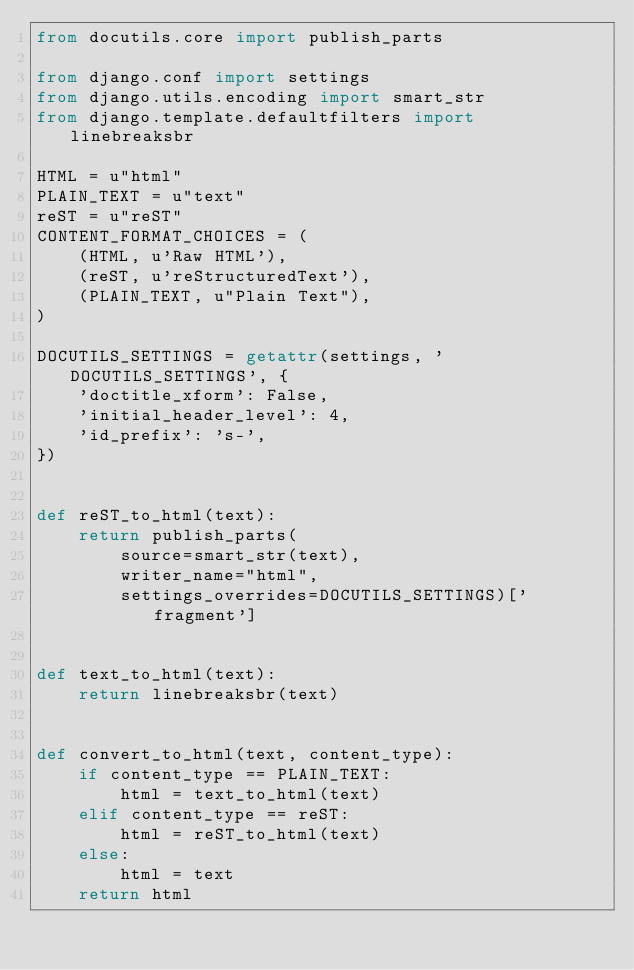<code> <loc_0><loc_0><loc_500><loc_500><_Python_>from docutils.core import publish_parts

from django.conf import settings
from django.utils.encoding import smart_str
from django.template.defaultfilters import linebreaksbr

HTML = u"html"
PLAIN_TEXT = u"text"
reST = u"reST"
CONTENT_FORMAT_CHOICES = (
    (HTML, u'Raw HTML'),
    (reST, u'reStructuredText'),
    (PLAIN_TEXT, u"Plain Text"),
)

DOCUTILS_SETTINGS = getattr(settings, 'DOCUTILS_SETTINGS', {
    'doctitle_xform': False,
    'initial_header_level': 4,
    'id_prefix': 's-',
})


def reST_to_html(text):
    return publish_parts(
        source=smart_str(text),
        writer_name="html",
        settings_overrides=DOCUTILS_SETTINGS)['fragment']


def text_to_html(text):
    return linebreaksbr(text)


def convert_to_html(text, content_type):
    if content_type == PLAIN_TEXT:
        html = text_to_html(text)
    elif content_type == reST:
        html = reST_to_html(text)
    else:
        html = text
    return html
</code> 